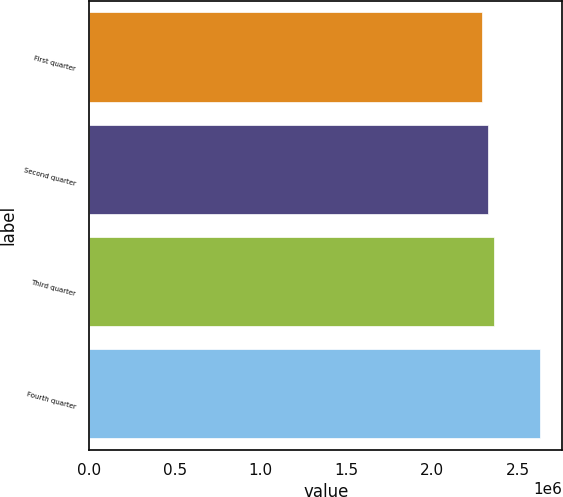Convert chart. <chart><loc_0><loc_0><loc_500><loc_500><bar_chart><fcel>First quarter<fcel>Second quarter<fcel>Third quarter<fcel>Fourth quarter<nl><fcel>2.29267e+06<fcel>2.3262e+06<fcel>2.35973e+06<fcel>2.62794e+06<nl></chart> 